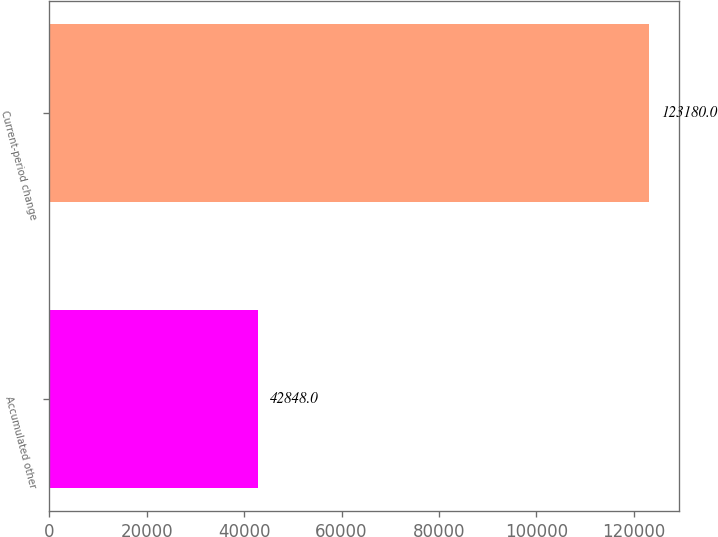Convert chart. <chart><loc_0><loc_0><loc_500><loc_500><bar_chart><fcel>Accumulated other<fcel>Current-period change<nl><fcel>42848<fcel>123180<nl></chart> 